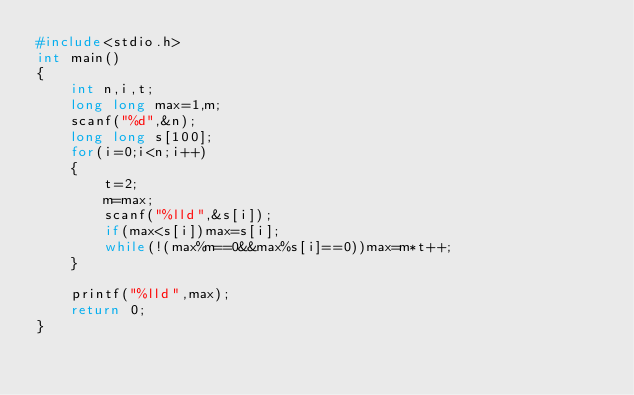<code> <loc_0><loc_0><loc_500><loc_500><_C_>#include<stdio.h>
int main()
{
    int n,i,t;
    long long max=1,m;
    scanf("%d",&n);
    long long s[100];
    for(i=0;i<n;i++)
    {
        t=2;
        m=max;
        scanf("%lld",&s[i]);
        if(max<s[i])max=s[i];
        while(!(max%m==0&&max%s[i]==0))max=m*t++;
    }

    printf("%lld",max);
    return 0;
}
</code> 